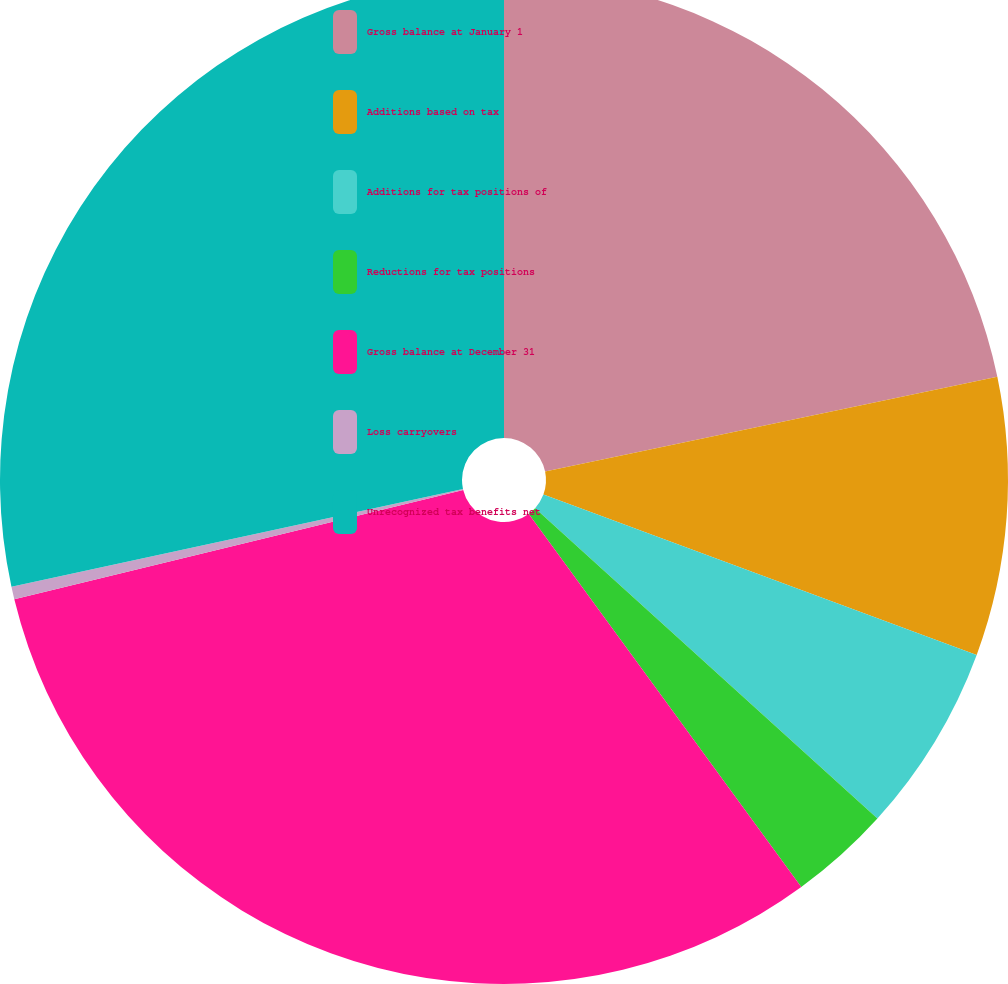<chart> <loc_0><loc_0><loc_500><loc_500><pie_chart><fcel>Gross balance at January 1<fcel>Additions based on tax<fcel>Additions for tax positions of<fcel>Reductions for tax positions<fcel>Gross balance at December 31<fcel>Loss carryovers<fcel>Unrecognized tax benefits net<nl><fcel>21.72%<fcel>8.92%<fcel>6.08%<fcel>3.24%<fcel>31.24%<fcel>0.4%<fcel>28.4%<nl></chart> 